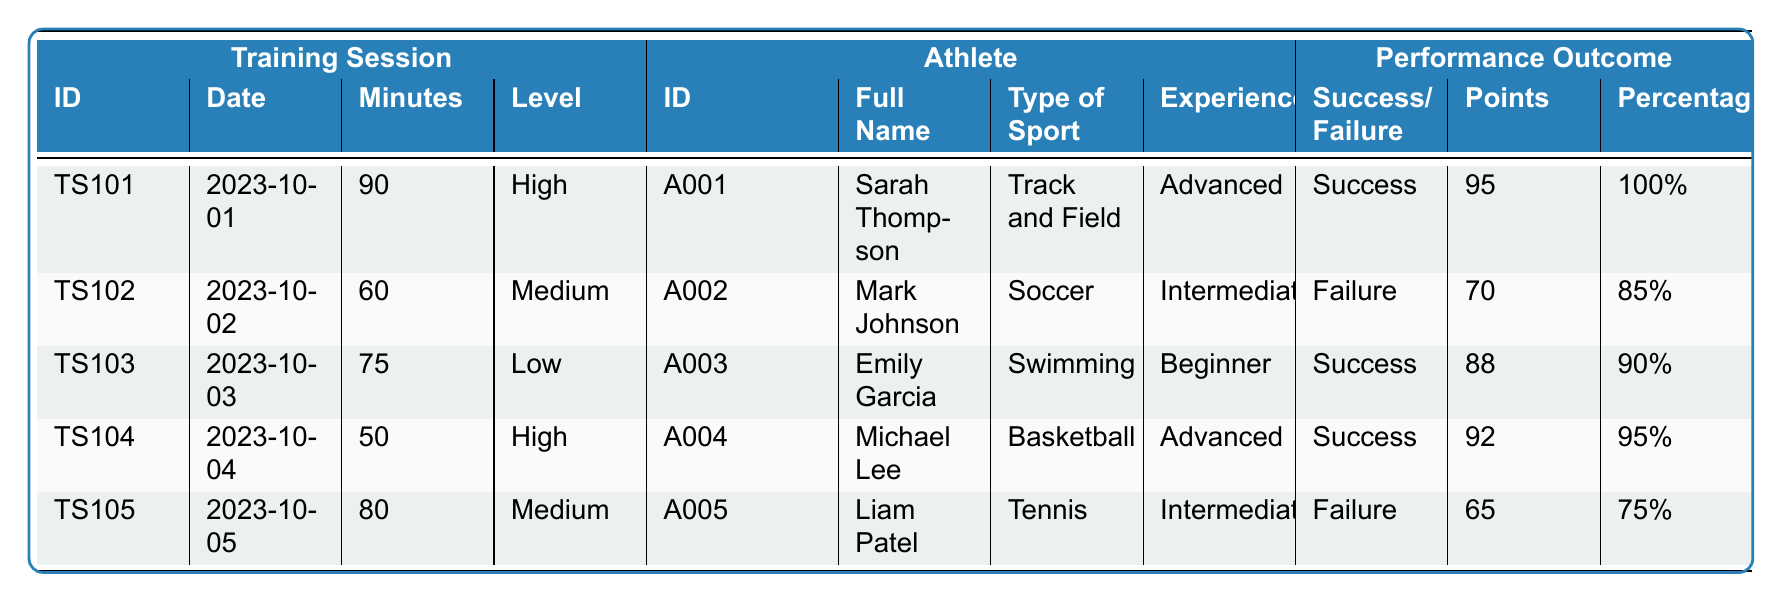What is the outcome of Sarah Thompson's training session? In the table, Sarah Thompson's training session (SessionID TS101) shows an outcome of "Success."
Answer: Success Which athlete has the highest completion rate? The completion rates are 100% for Sarah Thompson, 85% for Mark Johnson, 90% for Emily Garcia, 95% for Michael Lee, and 75% for Liam Patel. Sarah Thompson has the highest completion rate at 100%.
Answer: Sarah Thompson How many training sessions resulted in a failure? The table indicates that Mark Johnson (TS102) and Liam Patel (TS105) had failures as their outcomes. Therefore, there are two sessions that resulted in failures.
Answer: 2 What was the duration of the longest training session? The training sessions have durations of 90, 60, 75, 50, and 80 minutes. The longest duration is 90 minutes (by Sarah Thompson).
Answer: 90 minutes What is the average score of all athletes? The scores are 95, 70, 88, 92, and 65. The sum is 95 + 70 + 88 + 92 + 65 = 410. There are 5 athletes, so the average score is 410 / 5 = 82.
Answer: 82 Did Michael Lee experience success in his training session? According to the table, Michael Lee, during his session (TS104), had an outcome of "Success."
Answer: Yes What percentage of completed points does Liam Patel have? Liam Patel's session shows a completion rate of 75%.
Answer: 75% Which athlete has the lowest score, and what is that score? The scores listed are 95, 70, 88, 92, and 65. The lowest score is 65, which belongs to Liam Patel.
Answer: Liam Patel, 65 What is the difference in completion rates between the highest (Sarah Thompson) and the lowest (Liam Patel)? Sarah Thompson has a completion rate of 100%, while Liam Patel has a completion rate of 75%. The difference is 100% - 75% = 25%.
Answer: 25% How many athletes are classified as advanced? Looking at the experience levels, Sarah Thompson and Michael Lee are the only ones classified as advanced. That makes a total of two advanced athletes.
Answer: 2 Is there any training session with a duration greater than 80 minutes? The durations are 90, 60, 75, 50, and 80 minutes. Only Sarah Thompson's session exceeds 80 minutes, at 90.
Answer: Yes 